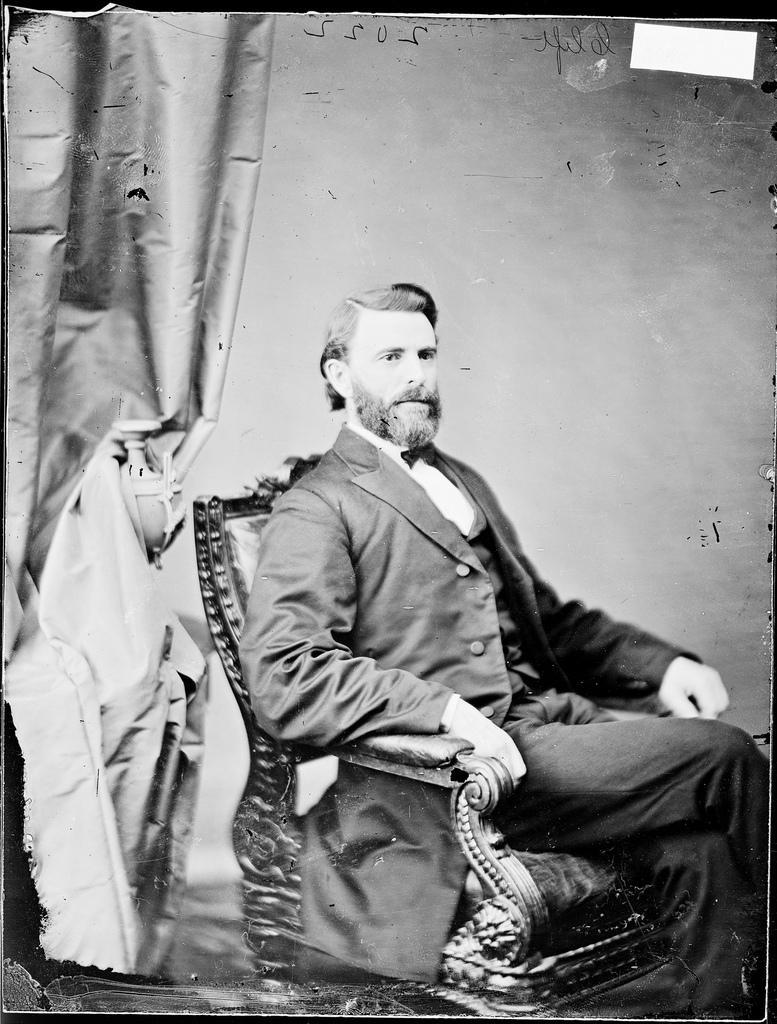Who is present in the image? There is a man in the image. What is the man doing in the image? The man is sitting in a chair. What is the man wearing in the image? The man is wearing a black suit. What can be seen in the background of the image? There is a wall in the background of the image. What is on the left side of the image? There is a curtain on the left side of the image. Is the man paying his taxes in the image? There is no indication in the image that the man is paying taxes. 